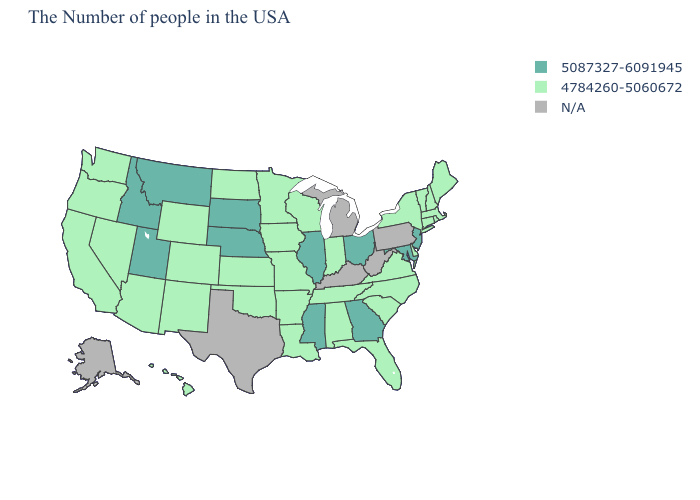Is the legend a continuous bar?
Give a very brief answer. No. Does Montana have the highest value in the West?
Short answer required. Yes. What is the value of Utah?
Concise answer only. 5087327-6091945. What is the lowest value in the MidWest?
Quick response, please. 4784260-5060672. What is the value of Wisconsin?
Concise answer only. 4784260-5060672. Which states have the lowest value in the USA?
Give a very brief answer. Maine, Massachusetts, Rhode Island, New Hampshire, Vermont, Connecticut, New York, Delaware, Virginia, North Carolina, South Carolina, Florida, Indiana, Alabama, Tennessee, Wisconsin, Louisiana, Missouri, Arkansas, Minnesota, Iowa, Kansas, Oklahoma, North Dakota, Wyoming, Colorado, New Mexico, Arizona, Nevada, California, Washington, Oregon, Hawaii. Does North Dakota have the lowest value in the MidWest?
Keep it brief. Yes. What is the value of Pennsylvania?
Concise answer only. N/A. Among the states that border Nebraska , does Iowa have the lowest value?
Answer briefly. Yes. Does North Carolina have the lowest value in the South?
Give a very brief answer. Yes. Name the states that have a value in the range 4784260-5060672?
Concise answer only. Maine, Massachusetts, Rhode Island, New Hampshire, Vermont, Connecticut, New York, Delaware, Virginia, North Carolina, South Carolina, Florida, Indiana, Alabama, Tennessee, Wisconsin, Louisiana, Missouri, Arkansas, Minnesota, Iowa, Kansas, Oklahoma, North Dakota, Wyoming, Colorado, New Mexico, Arizona, Nevada, California, Washington, Oregon, Hawaii. Among the states that border New York , does Vermont have the lowest value?
Short answer required. Yes. Name the states that have a value in the range 4784260-5060672?
Quick response, please. Maine, Massachusetts, Rhode Island, New Hampshire, Vermont, Connecticut, New York, Delaware, Virginia, North Carolina, South Carolina, Florida, Indiana, Alabama, Tennessee, Wisconsin, Louisiana, Missouri, Arkansas, Minnesota, Iowa, Kansas, Oklahoma, North Dakota, Wyoming, Colorado, New Mexico, Arizona, Nevada, California, Washington, Oregon, Hawaii. What is the value of North Dakota?
Short answer required. 4784260-5060672. What is the value of North Carolina?
Keep it brief. 4784260-5060672. 